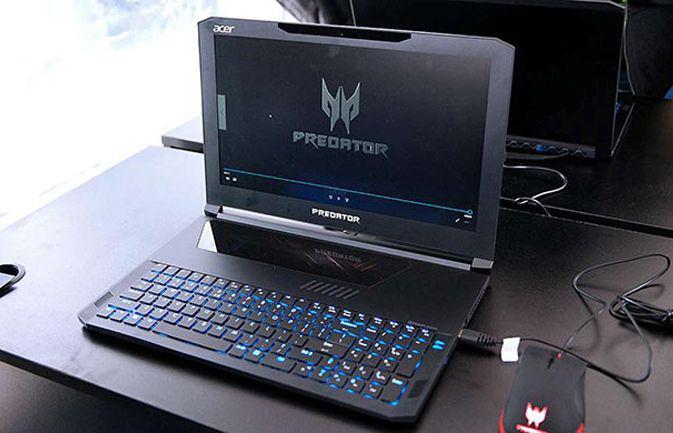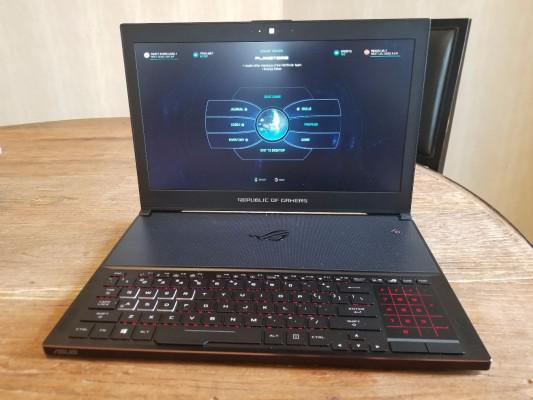The first image is the image on the left, the second image is the image on the right. Analyze the images presented: Is the assertion "there is a laptop sitting on a wooden table" valid? Answer yes or no. Yes. The first image is the image on the left, the second image is the image on the right. Examine the images to the left and right. Is the description "Wires are coming out the right side of the computer in at least one of the images." accurate? Answer yes or no. Yes. 